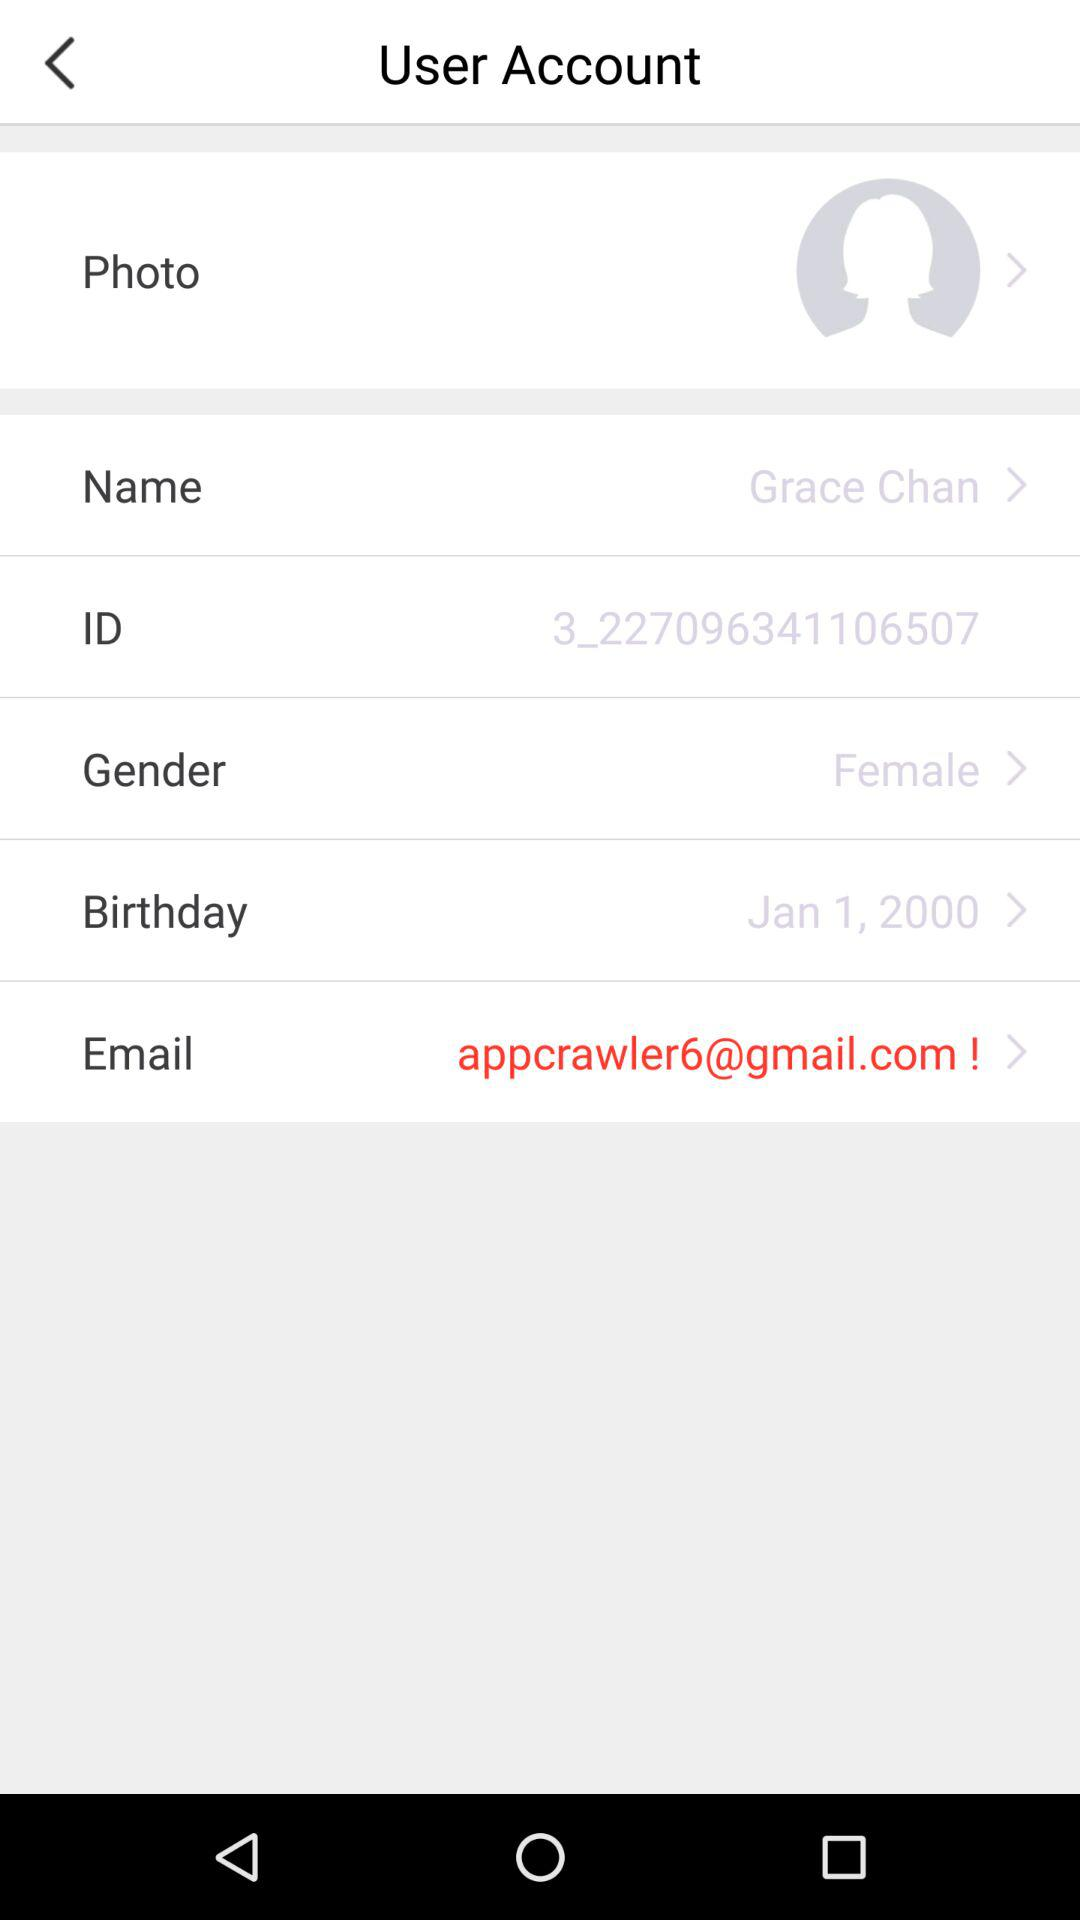What is the email address? The email address is appcrawler6@gmail.com. 